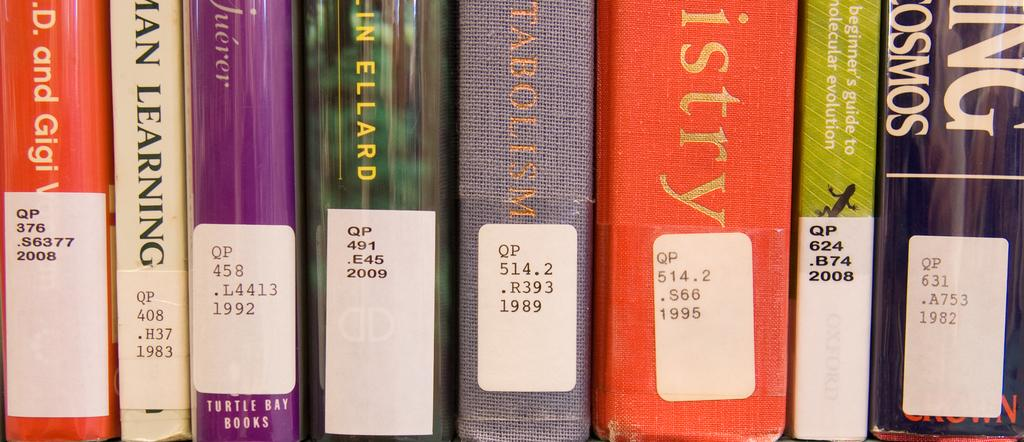<image>
Provide a brief description of the given image. a few books with one that says Ellard on it 